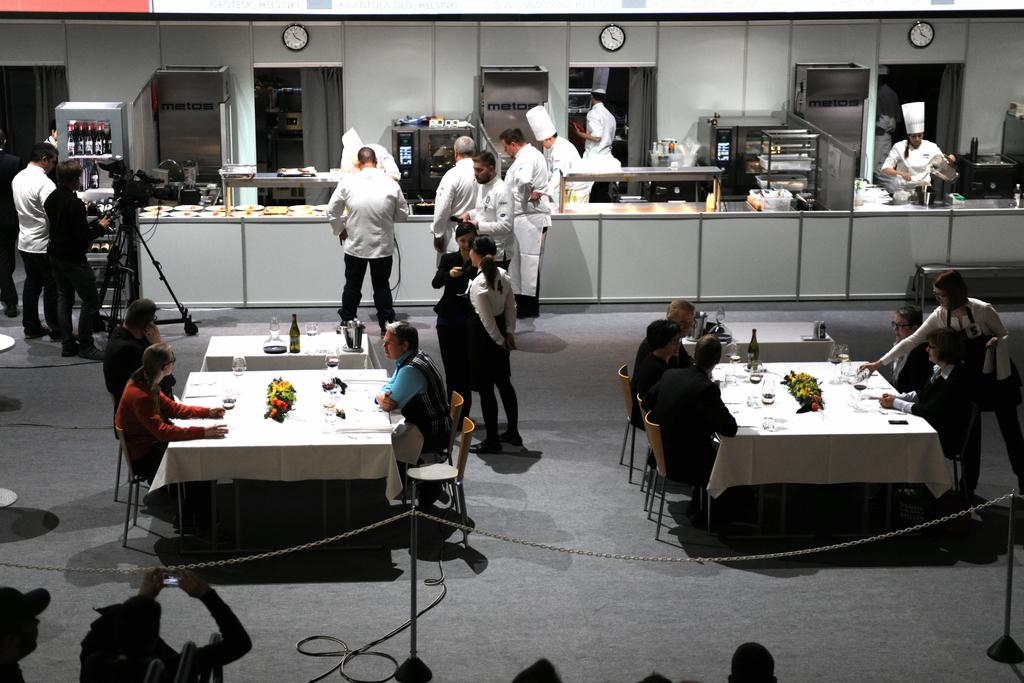How many people are in the image? There is a group of persons in the image. What are the positions of the persons in the image? Some of the persons are sitting, and some are standing. What can be seen in the background of the image? There are kitchen items visible in the background of the image. What type of cough can be heard from the girls in the image? There are no girls present in the image, and no sounds are mentioned or depicted. 